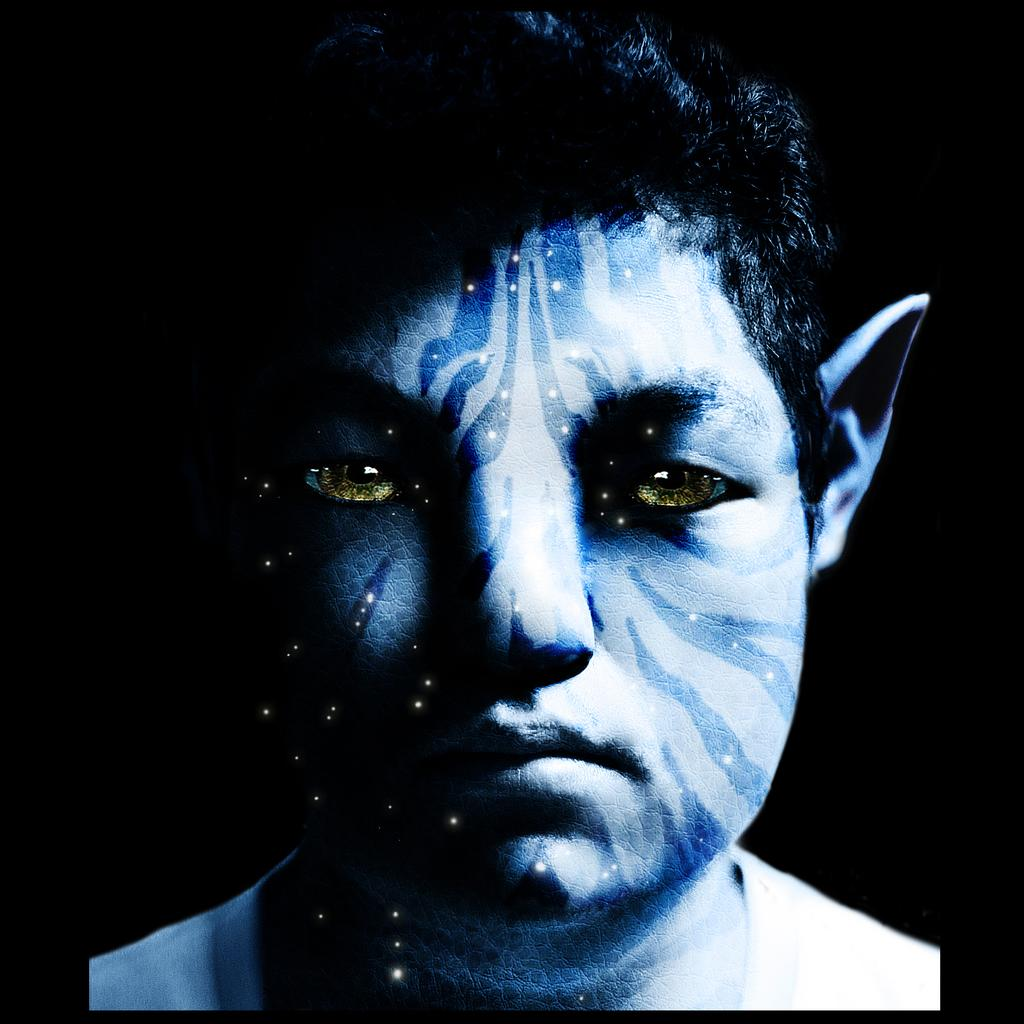What is the main subject of the image? There is an avatar in the image. Can you describe the background of the image? The background of the image is dark. How many pets are visible in the image? There are no pets visible in the image; it features an avatar and a dark background. What type of vehicle is the avatar driving in the image? There is no vehicle or driving depicted in the image; it only features an avatar and a dark background. 